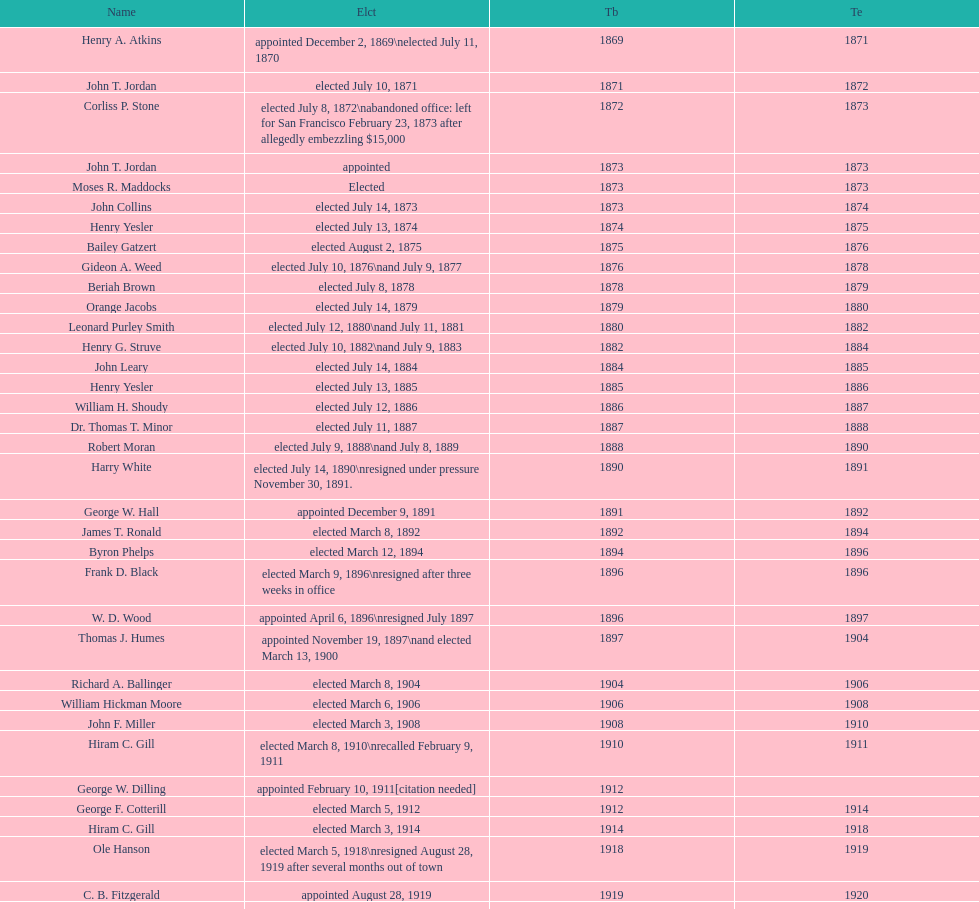Who was the first mayor in the 1900's? Richard A. Ballinger. 